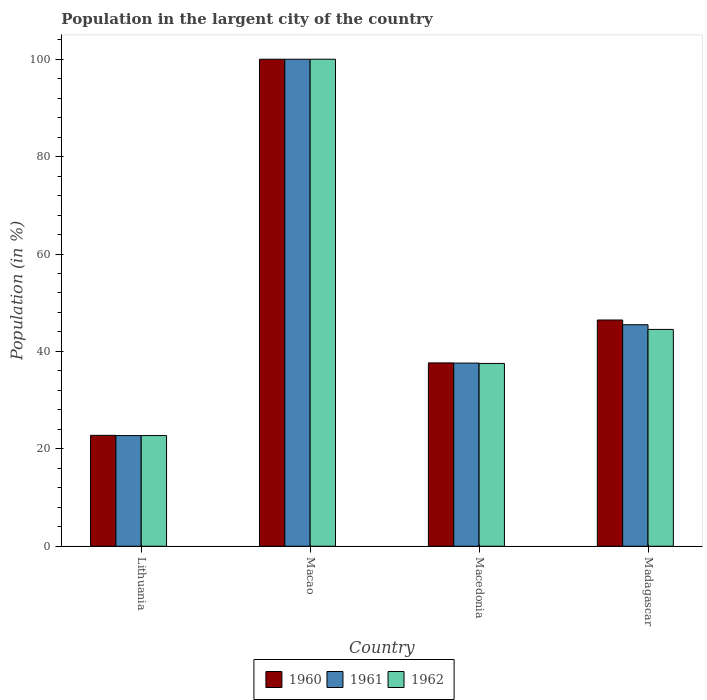How many different coloured bars are there?
Offer a terse response. 3. How many groups of bars are there?
Offer a very short reply. 4. Are the number of bars per tick equal to the number of legend labels?
Provide a succinct answer. Yes. How many bars are there on the 3rd tick from the left?
Your answer should be very brief. 3. How many bars are there on the 1st tick from the right?
Provide a short and direct response. 3. What is the label of the 4th group of bars from the left?
Provide a short and direct response. Madagascar. What is the percentage of population in the largent city in 1961 in Macedonia?
Your response must be concise. 37.61. Across all countries, what is the minimum percentage of population in the largent city in 1961?
Provide a short and direct response. 22.72. In which country was the percentage of population in the largent city in 1960 maximum?
Provide a short and direct response. Macao. In which country was the percentage of population in the largent city in 1962 minimum?
Make the answer very short. Lithuania. What is the total percentage of population in the largent city in 1961 in the graph?
Your answer should be compact. 205.81. What is the difference between the percentage of population in the largent city in 1961 in Macao and that in Macedonia?
Ensure brevity in your answer.  62.39. What is the difference between the percentage of population in the largent city in 1960 in Madagascar and the percentage of population in the largent city in 1962 in Macao?
Keep it short and to the point. -53.55. What is the average percentage of population in the largent city in 1961 per country?
Ensure brevity in your answer.  51.45. What is the difference between the percentage of population in the largent city of/in 1960 and percentage of population in the largent city of/in 1961 in Lithuania?
Your answer should be compact. 0.05. In how many countries, is the percentage of population in the largent city in 1962 greater than 28 %?
Your answer should be compact. 3. What is the ratio of the percentage of population in the largent city in 1962 in Lithuania to that in Macedonia?
Keep it short and to the point. 0.61. Is the percentage of population in the largent city in 1961 in Lithuania less than that in Madagascar?
Provide a short and direct response. Yes. What is the difference between the highest and the second highest percentage of population in the largent city in 1961?
Keep it short and to the point. -62.39. What is the difference between the highest and the lowest percentage of population in the largent city in 1961?
Your answer should be very brief. 77.28. In how many countries, is the percentage of population in the largent city in 1961 greater than the average percentage of population in the largent city in 1961 taken over all countries?
Make the answer very short. 1. Is the sum of the percentage of population in the largent city in 1961 in Macao and Macedonia greater than the maximum percentage of population in the largent city in 1962 across all countries?
Ensure brevity in your answer.  Yes. What does the 2nd bar from the left in Macedonia represents?
Give a very brief answer. 1961. What is the difference between two consecutive major ticks on the Y-axis?
Provide a succinct answer. 20. Are the values on the major ticks of Y-axis written in scientific E-notation?
Give a very brief answer. No. Does the graph contain any zero values?
Keep it short and to the point. No. Does the graph contain grids?
Your answer should be compact. No. Where does the legend appear in the graph?
Keep it short and to the point. Bottom center. How many legend labels are there?
Your answer should be compact. 3. What is the title of the graph?
Your answer should be very brief. Population in the largent city of the country. Does "1987" appear as one of the legend labels in the graph?
Keep it short and to the point. No. What is the label or title of the X-axis?
Make the answer very short. Country. What is the label or title of the Y-axis?
Keep it short and to the point. Population (in %). What is the Population (in %) of 1960 in Lithuania?
Your answer should be compact. 22.77. What is the Population (in %) of 1961 in Lithuania?
Make the answer very short. 22.72. What is the Population (in %) of 1962 in Lithuania?
Give a very brief answer. 22.73. What is the Population (in %) in 1960 in Macao?
Keep it short and to the point. 100. What is the Population (in %) in 1961 in Macao?
Give a very brief answer. 100. What is the Population (in %) in 1960 in Macedonia?
Make the answer very short. 37.65. What is the Population (in %) in 1961 in Macedonia?
Your answer should be compact. 37.61. What is the Population (in %) in 1962 in Macedonia?
Offer a very short reply. 37.54. What is the Population (in %) of 1960 in Madagascar?
Keep it short and to the point. 46.45. What is the Population (in %) of 1961 in Madagascar?
Offer a terse response. 45.48. What is the Population (in %) in 1962 in Madagascar?
Provide a succinct answer. 44.52. Across all countries, what is the maximum Population (in %) in 1960?
Provide a succinct answer. 100. Across all countries, what is the maximum Population (in %) of 1961?
Your answer should be very brief. 100. Across all countries, what is the minimum Population (in %) of 1960?
Provide a short and direct response. 22.77. Across all countries, what is the minimum Population (in %) in 1961?
Your answer should be compact. 22.72. Across all countries, what is the minimum Population (in %) in 1962?
Keep it short and to the point. 22.73. What is the total Population (in %) of 1960 in the graph?
Keep it short and to the point. 206.88. What is the total Population (in %) in 1961 in the graph?
Offer a very short reply. 205.81. What is the total Population (in %) of 1962 in the graph?
Your answer should be very brief. 204.79. What is the difference between the Population (in %) of 1960 in Lithuania and that in Macao?
Your response must be concise. -77.23. What is the difference between the Population (in %) in 1961 in Lithuania and that in Macao?
Offer a very short reply. -77.28. What is the difference between the Population (in %) of 1962 in Lithuania and that in Macao?
Your response must be concise. -77.27. What is the difference between the Population (in %) of 1960 in Lithuania and that in Macedonia?
Your response must be concise. -14.87. What is the difference between the Population (in %) of 1961 in Lithuania and that in Macedonia?
Provide a short and direct response. -14.88. What is the difference between the Population (in %) in 1962 in Lithuania and that in Macedonia?
Provide a succinct answer. -14.81. What is the difference between the Population (in %) of 1960 in Lithuania and that in Madagascar?
Ensure brevity in your answer.  -23.68. What is the difference between the Population (in %) in 1961 in Lithuania and that in Madagascar?
Your answer should be compact. -22.76. What is the difference between the Population (in %) in 1962 in Lithuania and that in Madagascar?
Your answer should be compact. -21.8. What is the difference between the Population (in %) of 1960 in Macao and that in Macedonia?
Give a very brief answer. 62.35. What is the difference between the Population (in %) in 1961 in Macao and that in Macedonia?
Give a very brief answer. 62.39. What is the difference between the Population (in %) in 1962 in Macao and that in Macedonia?
Give a very brief answer. 62.46. What is the difference between the Population (in %) of 1960 in Macao and that in Madagascar?
Your answer should be compact. 53.55. What is the difference between the Population (in %) in 1961 in Macao and that in Madagascar?
Provide a succinct answer. 54.52. What is the difference between the Population (in %) of 1962 in Macao and that in Madagascar?
Ensure brevity in your answer.  55.48. What is the difference between the Population (in %) of 1960 in Macedonia and that in Madagascar?
Give a very brief answer. -8.81. What is the difference between the Population (in %) in 1961 in Macedonia and that in Madagascar?
Ensure brevity in your answer.  -7.88. What is the difference between the Population (in %) in 1962 in Macedonia and that in Madagascar?
Your answer should be very brief. -6.99. What is the difference between the Population (in %) of 1960 in Lithuania and the Population (in %) of 1961 in Macao?
Ensure brevity in your answer.  -77.23. What is the difference between the Population (in %) in 1960 in Lithuania and the Population (in %) in 1962 in Macao?
Make the answer very short. -77.23. What is the difference between the Population (in %) in 1961 in Lithuania and the Population (in %) in 1962 in Macao?
Your answer should be compact. -77.28. What is the difference between the Population (in %) in 1960 in Lithuania and the Population (in %) in 1961 in Macedonia?
Your response must be concise. -14.83. What is the difference between the Population (in %) of 1960 in Lithuania and the Population (in %) of 1962 in Macedonia?
Your answer should be compact. -14.76. What is the difference between the Population (in %) of 1961 in Lithuania and the Population (in %) of 1962 in Macedonia?
Ensure brevity in your answer.  -14.82. What is the difference between the Population (in %) in 1960 in Lithuania and the Population (in %) in 1961 in Madagascar?
Offer a very short reply. -22.71. What is the difference between the Population (in %) of 1960 in Lithuania and the Population (in %) of 1962 in Madagascar?
Your answer should be very brief. -21.75. What is the difference between the Population (in %) in 1961 in Lithuania and the Population (in %) in 1962 in Madagascar?
Provide a short and direct response. -21.8. What is the difference between the Population (in %) of 1960 in Macao and the Population (in %) of 1961 in Macedonia?
Provide a short and direct response. 62.39. What is the difference between the Population (in %) of 1960 in Macao and the Population (in %) of 1962 in Macedonia?
Offer a very short reply. 62.46. What is the difference between the Population (in %) of 1961 in Macao and the Population (in %) of 1962 in Macedonia?
Keep it short and to the point. 62.46. What is the difference between the Population (in %) in 1960 in Macao and the Population (in %) in 1961 in Madagascar?
Ensure brevity in your answer.  54.52. What is the difference between the Population (in %) in 1960 in Macao and the Population (in %) in 1962 in Madagascar?
Provide a short and direct response. 55.48. What is the difference between the Population (in %) of 1961 in Macao and the Population (in %) of 1962 in Madagascar?
Your answer should be compact. 55.48. What is the difference between the Population (in %) in 1960 in Macedonia and the Population (in %) in 1961 in Madagascar?
Offer a very short reply. -7.84. What is the difference between the Population (in %) of 1960 in Macedonia and the Population (in %) of 1962 in Madagascar?
Give a very brief answer. -6.88. What is the difference between the Population (in %) in 1961 in Macedonia and the Population (in %) in 1962 in Madagascar?
Offer a terse response. -6.92. What is the average Population (in %) in 1960 per country?
Make the answer very short. 51.72. What is the average Population (in %) of 1961 per country?
Your answer should be compact. 51.45. What is the average Population (in %) of 1962 per country?
Give a very brief answer. 51.2. What is the difference between the Population (in %) of 1960 and Population (in %) of 1961 in Lithuania?
Provide a short and direct response. 0.05. What is the difference between the Population (in %) in 1960 and Population (in %) in 1962 in Lithuania?
Give a very brief answer. 0.05. What is the difference between the Population (in %) of 1961 and Population (in %) of 1962 in Lithuania?
Offer a very short reply. -0. What is the difference between the Population (in %) in 1960 and Population (in %) in 1961 in Macao?
Offer a very short reply. 0. What is the difference between the Population (in %) in 1960 and Population (in %) in 1962 in Macao?
Your answer should be compact. 0. What is the difference between the Population (in %) in 1960 and Population (in %) in 1961 in Macedonia?
Keep it short and to the point. 0.04. What is the difference between the Population (in %) in 1960 and Population (in %) in 1962 in Macedonia?
Give a very brief answer. 0.11. What is the difference between the Population (in %) in 1961 and Population (in %) in 1962 in Macedonia?
Offer a terse response. 0.07. What is the difference between the Population (in %) of 1960 and Population (in %) of 1961 in Madagascar?
Make the answer very short. 0.97. What is the difference between the Population (in %) of 1960 and Population (in %) of 1962 in Madagascar?
Ensure brevity in your answer.  1.93. What is the difference between the Population (in %) in 1961 and Population (in %) in 1962 in Madagascar?
Ensure brevity in your answer.  0.96. What is the ratio of the Population (in %) in 1960 in Lithuania to that in Macao?
Keep it short and to the point. 0.23. What is the ratio of the Population (in %) of 1961 in Lithuania to that in Macao?
Offer a very short reply. 0.23. What is the ratio of the Population (in %) of 1962 in Lithuania to that in Macao?
Ensure brevity in your answer.  0.23. What is the ratio of the Population (in %) of 1960 in Lithuania to that in Macedonia?
Your answer should be very brief. 0.6. What is the ratio of the Population (in %) in 1961 in Lithuania to that in Macedonia?
Offer a very short reply. 0.6. What is the ratio of the Population (in %) of 1962 in Lithuania to that in Macedonia?
Keep it short and to the point. 0.61. What is the ratio of the Population (in %) in 1960 in Lithuania to that in Madagascar?
Offer a very short reply. 0.49. What is the ratio of the Population (in %) in 1961 in Lithuania to that in Madagascar?
Provide a succinct answer. 0.5. What is the ratio of the Population (in %) of 1962 in Lithuania to that in Madagascar?
Offer a very short reply. 0.51. What is the ratio of the Population (in %) in 1960 in Macao to that in Macedonia?
Give a very brief answer. 2.66. What is the ratio of the Population (in %) of 1961 in Macao to that in Macedonia?
Provide a short and direct response. 2.66. What is the ratio of the Population (in %) of 1962 in Macao to that in Macedonia?
Provide a short and direct response. 2.66. What is the ratio of the Population (in %) of 1960 in Macao to that in Madagascar?
Ensure brevity in your answer.  2.15. What is the ratio of the Population (in %) of 1961 in Macao to that in Madagascar?
Your answer should be compact. 2.2. What is the ratio of the Population (in %) of 1962 in Macao to that in Madagascar?
Make the answer very short. 2.25. What is the ratio of the Population (in %) in 1960 in Macedonia to that in Madagascar?
Offer a terse response. 0.81. What is the ratio of the Population (in %) of 1961 in Macedonia to that in Madagascar?
Provide a succinct answer. 0.83. What is the ratio of the Population (in %) of 1962 in Macedonia to that in Madagascar?
Keep it short and to the point. 0.84. What is the difference between the highest and the second highest Population (in %) of 1960?
Make the answer very short. 53.55. What is the difference between the highest and the second highest Population (in %) of 1961?
Provide a succinct answer. 54.52. What is the difference between the highest and the second highest Population (in %) in 1962?
Provide a succinct answer. 55.48. What is the difference between the highest and the lowest Population (in %) in 1960?
Your answer should be compact. 77.23. What is the difference between the highest and the lowest Population (in %) of 1961?
Your response must be concise. 77.28. What is the difference between the highest and the lowest Population (in %) of 1962?
Your answer should be very brief. 77.27. 